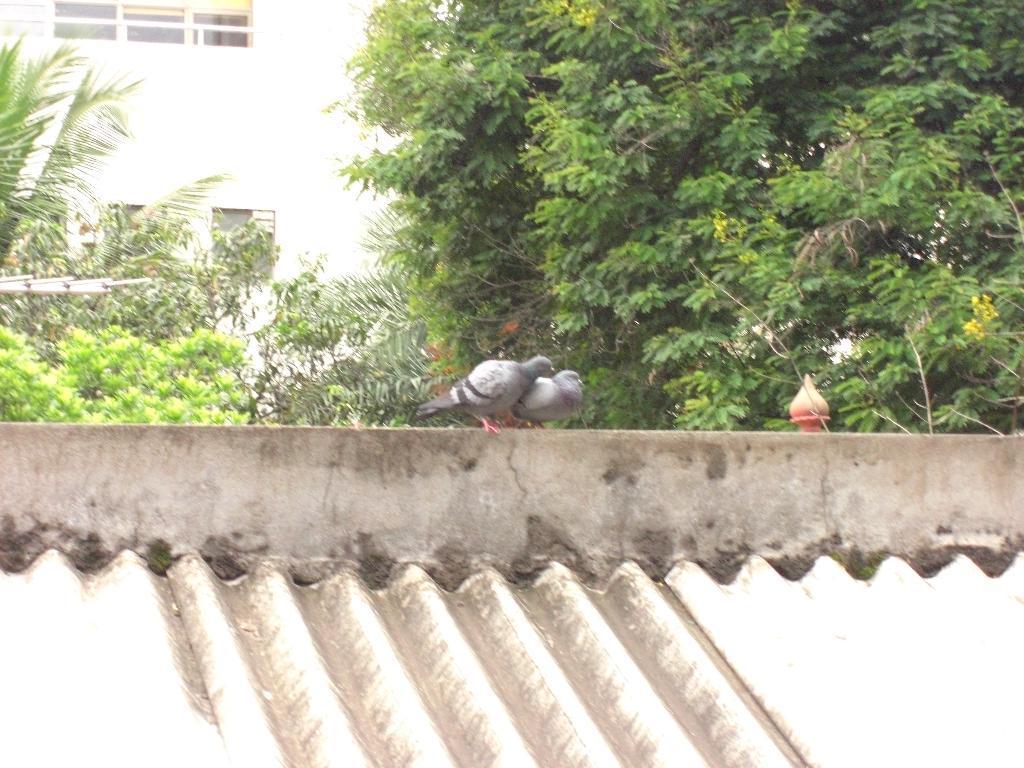Describe this image in one or two sentences. In the center of the image there is a wall and roof. On the wall, we can see one orange color object and two pigeons. In the background there is a building, windows, trees and a few other objects. 